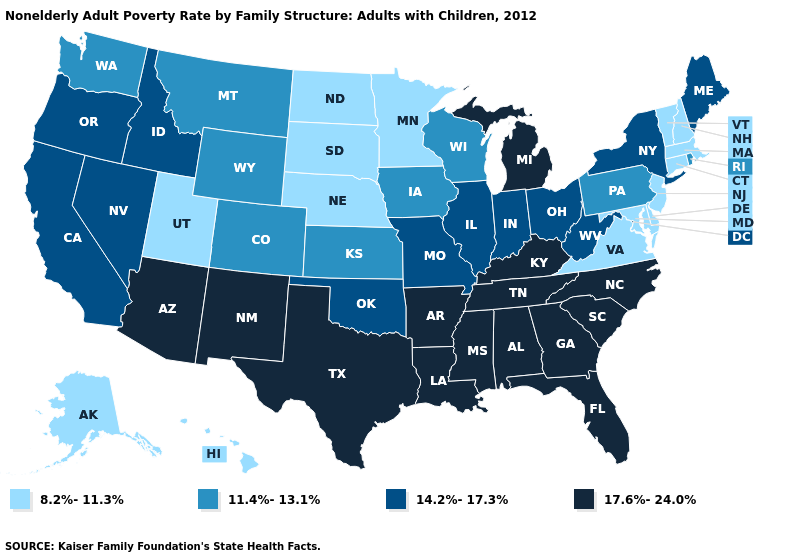Name the states that have a value in the range 11.4%-13.1%?
Answer briefly. Colorado, Iowa, Kansas, Montana, Pennsylvania, Rhode Island, Washington, Wisconsin, Wyoming. Name the states that have a value in the range 11.4%-13.1%?
Concise answer only. Colorado, Iowa, Kansas, Montana, Pennsylvania, Rhode Island, Washington, Wisconsin, Wyoming. Does Louisiana have a lower value than Maine?
Answer briefly. No. What is the value of California?
Keep it brief. 14.2%-17.3%. Name the states that have a value in the range 14.2%-17.3%?
Be succinct. California, Idaho, Illinois, Indiana, Maine, Missouri, Nevada, New York, Ohio, Oklahoma, Oregon, West Virginia. Among the states that border Ohio , does Kentucky have the highest value?
Be succinct. Yes. Name the states that have a value in the range 17.6%-24.0%?
Short answer required. Alabama, Arizona, Arkansas, Florida, Georgia, Kentucky, Louisiana, Michigan, Mississippi, New Mexico, North Carolina, South Carolina, Tennessee, Texas. What is the value of South Carolina?
Keep it brief. 17.6%-24.0%. What is the value of Kansas?
Concise answer only. 11.4%-13.1%. Does Maine have the lowest value in the USA?
Concise answer only. No. Does the first symbol in the legend represent the smallest category?
Answer briefly. Yes. Is the legend a continuous bar?
Keep it brief. No. What is the highest value in states that border New Mexico?
Answer briefly. 17.6%-24.0%. What is the lowest value in the USA?
Concise answer only. 8.2%-11.3%. Does Pennsylvania have the lowest value in the Northeast?
Write a very short answer. No. 